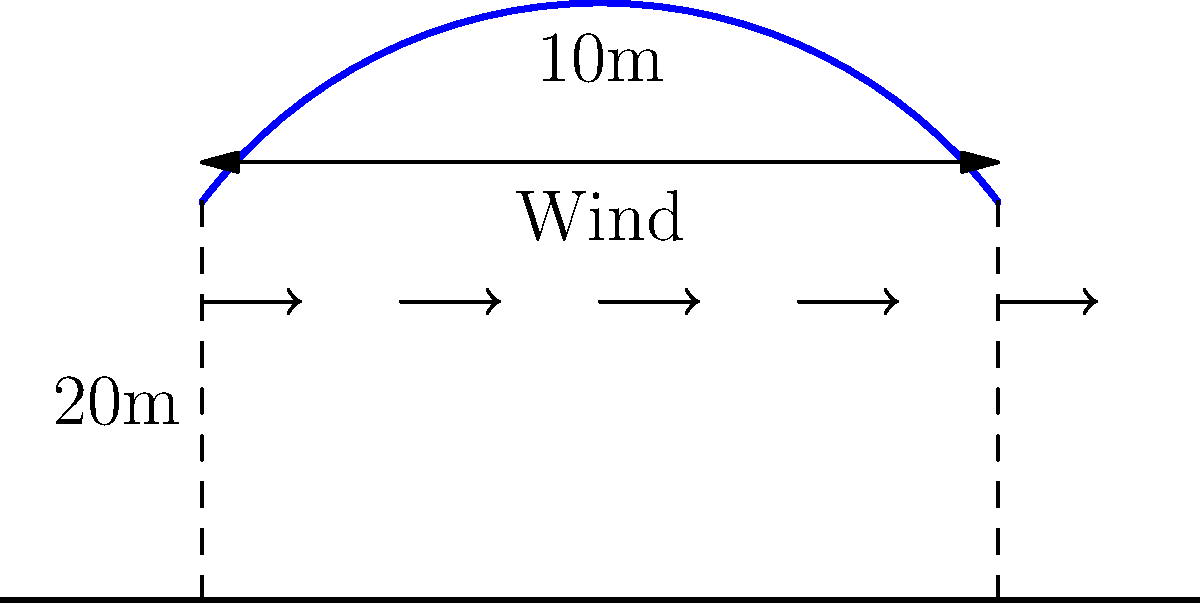For an outdoor music festival, you're designing a large fabric canopy structure. The canopy has a curved shape as shown in the diagram, with a span of 20m and a maximum height of 10m. If the basic wind speed is 30 m/s and the terrain category is open country (Terrain Category 2), calculate the design wind pressure on the canopy. Assume a topography factor of 1.0 and an importance factor of 1.0. Use the simplified method from AS/NZS 1170.2. To calculate the design wind pressure, we'll follow these steps:

1) First, calculate the design wind speed:
   $V_{des} = V_R \times M_d \times M_z,cat \times M_s \times M_t$
   Where:
   $V_R$ = regional wind speed (given as 30 m/s)
   $M_d$ = wind directional multiplier (assume 1.0 for simplicity)
   $M_z,cat$ = terrain/height multiplier (for 10m height in Category 2, it's approximately 0.91)
   $M_s$ = shielding multiplier (assume 1.0 for no shielding)
   $M_t$ = topographic multiplier (given as 1.0)

   So, $V_{des} = 30 \times 1.0 \times 0.91 \times 1.0 \times 1.0 = 27.3$ m/s

2) Calculate the design wind pressure:
   $p = 0.5 \times \rho \times V_{des}^2 \times C_{fig}$
   Where:
   $\rho$ = air density (typically 1.2 kg/m³)
   $C_{fig}$ = aerodynamic shape factor (for a curved roof, typically around 0.7)

   So, $p = 0.5 \times 1.2 \times 27.3^2 \times 0.7 = 313.4$ Pa

3) Apply the importance factor:
   $p_{design} = p \times I$
   Where $I$ = importance factor (given as 1.0)

   So, $p_{design} = 313.4 \times 1.0 = 313.4$ Pa

Therefore, the design wind pressure on the canopy is approximately 313.4 Pa or 0.31 kPa.
Answer: 0.31 kPa 